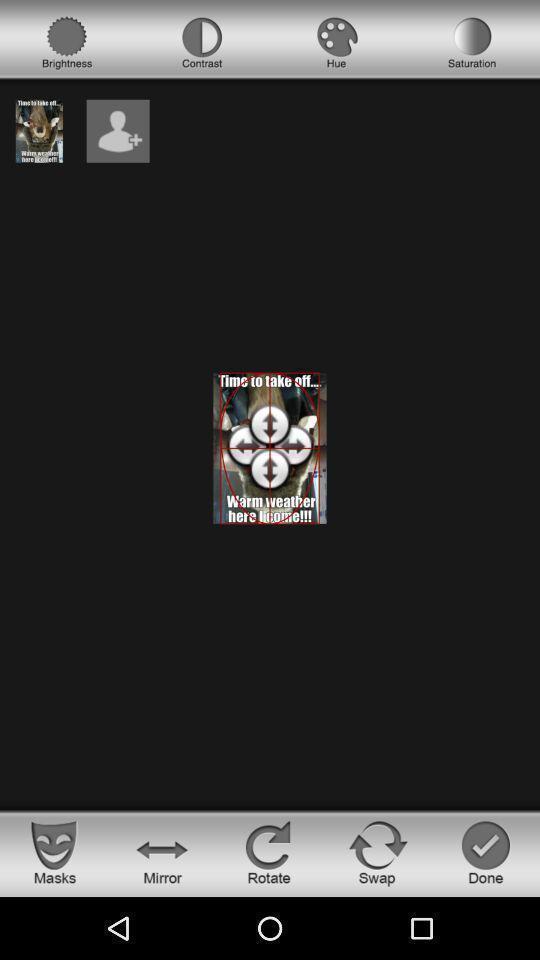Explain what's happening in this screen capture. Screen showing page with options. 